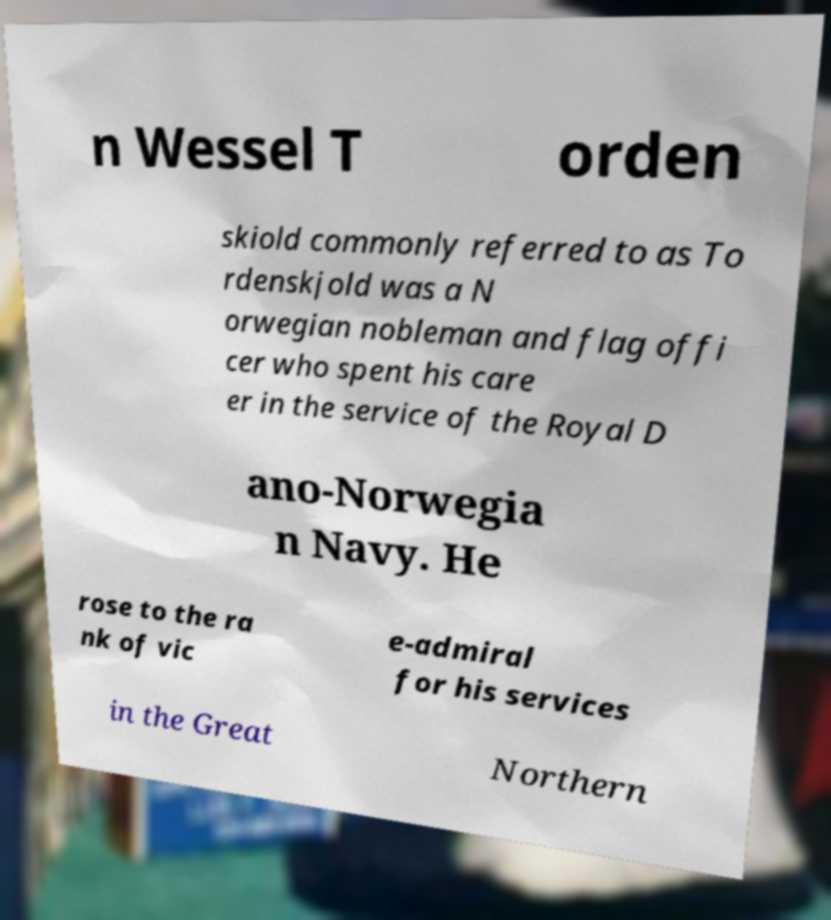Please identify and transcribe the text found in this image. n Wessel T orden skiold commonly referred to as To rdenskjold was a N orwegian nobleman and flag offi cer who spent his care er in the service of the Royal D ano-Norwegia n Navy. He rose to the ra nk of vic e-admiral for his services in the Great Northern 